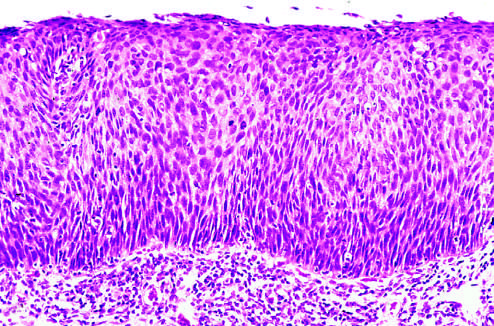s the basement membrane intact?
Answer the question using a single word or phrase. Yes 